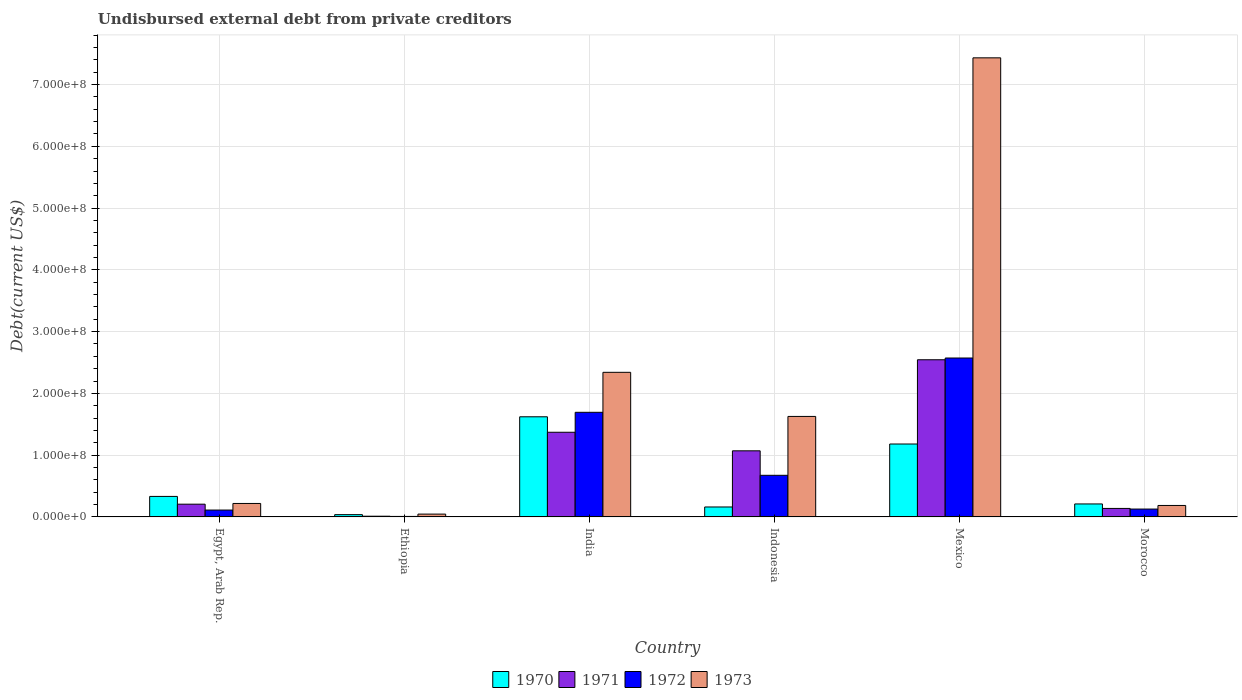How many different coloured bars are there?
Offer a terse response. 4. Are the number of bars on each tick of the X-axis equal?
Your answer should be very brief. Yes. How many bars are there on the 2nd tick from the left?
Your answer should be very brief. 4. What is the label of the 4th group of bars from the left?
Give a very brief answer. Indonesia. In how many cases, is the number of bars for a given country not equal to the number of legend labels?
Keep it short and to the point. 0. What is the total debt in 1971 in Indonesia?
Your answer should be very brief. 1.07e+08. Across all countries, what is the maximum total debt in 1970?
Your response must be concise. 1.62e+08. Across all countries, what is the minimum total debt in 1971?
Provide a succinct answer. 1.16e+06. In which country was the total debt in 1972 maximum?
Offer a very short reply. Mexico. In which country was the total debt in 1971 minimum?
Your answer should be compact. Ethiopia. What is the total total debt in 1971 in the graph?
Offer a very short reply. 5.34e+08. What is the difference between the total debt in 1973 in Egypt, Arab Rep. and that in India?
Your response must be concise. -2.12e+08. What is the difference between the total debt in 1972 in Mexico and the total debt in 1970 in India?
Your answer should be very brief. 9.51e+07. What is the average total debt in 1970 per country?
Ensure brevity in your answer.  5.90e+07. What is the difference between the total debt of/in 1973 and total debt of/in 1970 in Indonesia?
Make the answer very short. 1.47e+08. In how many countries, is the total debt in 1973 greater than 700000000 US$?
Provide a short and direct response. 1. What is the ratio of the total debt in 1973 in Ethiopia to that in India?
Make the answer very short. 0.02. Is the total debt in 1971 in Egypt, Arab Rep. less than that in Indonesia?
Your response must be concise. Yes. Is the difference between the total debt in 1973 in India and Indonesia greater than the difference between the total debt in 1970 in India and Indonesia?
Ensure brevity in your answer.  No. What is the difference between the highest and the second highest total debt in 1972?
Offer a terse response. 1.90e+08. What is the difference between the highest and the lowest total debt in 1970?
Make the answer very short. 1.58e+08. Is the sum of the total debt in 1973 in India and Indonesia greater than the maximum total debt in 1972 across all countries?
Keep it short and to the point. Yes. What does the 1st bar from the left in Mexico represents?
Offer a terse response. 1970. How many countries are there in the graph?
Give a very brief answer. 6. Does the graph contain grids?
Offer a terse response. Yes. How many legend labels are there?
Provide a short and direct response. 4. How are the legend labels stacked?
Give a very brief answer. Horizontal. What is the title of the graph?
Provide a short and direct response. Undisbursed external debt from private creditors. What is the label or title of the X-axis?
Make the answer very short. Country. What is the label or title of the Y-axis?
Keep it short and to the point. Debt(current US$). What is the Debt(current US$) in 1970 in Egypt, Arab Rep.?
Offer a very short reply. 3.32e+07. What is the Debt(current US$) of 1971 in Egypt, Arab Rep.?
Provide a succinct answer. 2.06e+07. What is the Debt(current US$) in 1972 in Egypt, Arab Rep.?
Offer a very short reply. 1.11e+07. What is the Debt(current US$) of 1973 in Egypt, Arab Rep.?
Ensure brevity in your answer.  2.18e+07. What is the Debt(current US$) in 1970 in Ethiopia?
Ensure brevity in your answer.  3.70e+06. What is the Debt(current US$) of 1971 in Ethiopia?
Offer a terse response. 1.16e+06. What is the Debt(current US$) of 1972 in Ethiopia?
Keep it short and to the point. 8.20e+05. What is the Debt(current US$) in 1973 in Ethiopia?
Provide a short and direct response. 4.57e+06. What is the Debt(current US$) in 1970 in India?
Your answer should be very brief. 1.62e+08. What is the Debt(current US$) of 1971 in India?
Give a very brief answer. 1.37e+08. What is the Debt(current US$) of 1972 in India?
Offer a very short reply. 1.69e+08. What is the Debt(current US$) in 1973 in India?
Offer a very short reply. 2.34e+08. What is the Debt(current US$) in 1970 in Indonesia?
Make the answer very short. 1.61e+07. What is the Debt(current US$) of 1971 in Indonesia?
Offer a very short reply. 1.07e+08. What is the Debt(current US$) in 1972 in Indonesia?
Offer a very short reply. 6.74e+07. What is the Debt(current US$) in 1973 in Indonesia?
Ensure brevity in your answer.  1.63e+08. What is the Debt(current US$) of 1970 in Mexico?
Give a very brief answer. 1.18e+08. What is the Debt(current US$) of 1971 in Mexico?
Ensure brevity in your answer.  2.54e+08. What is the Debt(current US$) in 1972 in Mexico?
Keep it short and to the point. 2.57e+08. What is the Debt(current US$) of 1973 in Mexico?
Ensure brevity in your answer.  7.43e+08. What is the Debt(current US$) of 1970 in Morocco?
Your response must be concise. 2.10e+07. What is the Debt(current US$) in 1971 in Morocco?
Ensure brevity in your answer.  1.37e+07. What is the Debt(current US$) of 1972 in Morocco?
Keep it short and to the point. 1.27e+07. What is the Debt(current US$) of 1973 in Morocco?
Offer a very short reply. 1.86e+07. Across all countries, what is the maximum Debt(current US$) of 1970?
Your answer should be very brief. 1.62e+08. Across all countries, what is the maximum Debt(current US$) of 1971?
Make the answer very short. 2.54e+08. Across all countries, what is the maximum Debt(current US$) of 1972?
Your response must be concise. 2.57e+08. Across all countries, what is the maximum Debt(current US$) in 1973?
Provide a succinct answer. 7.43e+08. Across all countries, what is the minimum Debt(current US$) in 1970?
Your response must be concise. 3.70e+06. Across all countries, what is the minimum Debt(current US$) in 1971?
Provide a short and direct response. 1.16e+06. Across all countries, what is the minimum Debt(current US$) in 1972?
Offer a terse response. 8.20e+05. Across all countries, what is the minimum Debt(current US$) in 1973?
Make the answer very short. 4.57e+06. What is the total Debt(current US$) of 1970 in the graph?
Make the answer very short. 3.54e+08. What is the total Debt(current US$) in 1971 in the graph?
Provide a succinct answer. 5.34e+08. What is the total Debt(current US$) of 1972 in the graph?
Provide a short and direct response. 5.19e+08. What is the total Debt(current US$) in 1973 in the graph?
Give a very brief answer. 1.18e+09. What is the difference between the Debt(current US$) of 1970 in Egypt, Arab Rep. and that in Ethiopia?
Offer a terse response. 2.95e+07. What is the difference between the Debt(current US$) in 1971 in Egypt, Arab Rep. and that in Ethiopia?
Provide a short and direct response. 1.95e+07. What is the difference between the Debt(current US$) of 1972 in Egypt, Arab Rep. and that in Ethiopia?
Keep it short and to the point. 1.03e+07. What is the difference between the Debt(current US$) of 1973 in Egypt, Arab Rep. and that in Ethiopia?
Offer a terse response. 1.72e+07. What is the difference between the Debt(current US$) in 1970 in Egypt, Arab Rep. and that in India?
Ensure brevity in your answer.  -1.29e+08. What is the difference between the Debt(current US$) in 1971 in Egypt, Arab Rep. and that in India?
Keep it short and to the point. -1.16e+08. What is the difference between the Debt(current US$) of 1972 in Egypt, Arab Rep. and that in India?
Give a very brief answer. -1.58e+08. What is the difference between the Debt(current US$) in 1973 in Egypt, Arab Rep. and that in India?
Provide a succinct answer. -2.12e+08. What is the difference between the Debt(current US$) in 1970 in Egypt, Arab Rep. and that in Indonesia?
Ensure brevity in your answer.  1.71e+07. What is the difference between the Debt(current US$) in 1971 in Egypt, Arab Rep. and that in Indonesia?
Your answer should be very brief. -8.64e+07. What is the difference between the Debt(current US$) of 1972 in Egypt, Arab Rep. and that in Indonesia?
Keep it short and to the point. -5.62e+07. What is the difference between the Debt(current US$) of 1973 in Egypt, Arab Rep. and that in Indonesia?
Ensure brevity in your answer.  -1.41e+08. What is the difference between the Debt(current US$) of 1970 in Egypt, Arab Rep. and that in Mexico?
Make the answer very short. -8.48e+07. What is the difference between the Debt(current US$) of 1971 in Egypt, Arab Rep. and that in Mexico?
Your answer should be very brief. -2.34e+08. What is the difference between the Debt(current US$) in 1972 in Egypt, Arab Rep. and that in Mexico?
Make the answer very short. -2.46e+08. What is the difference between the Debt(current US$) in 1973 in Egypt, Arab Rep. and that in Mexico?
Keep it short and to the point. -7.21e+08. What is the difference between the Debt(current US$) of 1970 in Egypt, Arab Rep. and that in Morocco?
Your response must be concise. 1.22e+07. What is the difference between the Debt(current US$) in 1971 in Egypt, Arab Rep. and that in Morocco?
Provide a short and direct response. 6.88e+06. What is the difference between the Debt(current US$) of 1972 in Egypt, Arab Rep. and that in Morocco?
Your answer should be compact. -1.61e+06. What is the difference between the Debt(current US$) in 1973 in Egypt, Arab Rep. and that in Morocco?
Your answer should be very brief. 3.24e+06. What is the difference between the Debt(current US$) in 1970 in Ethiopia and that in India?
Provide a short and direct response. -1.58e+08. What is the difference between the Debt(current US$) of 1971 in Ethiopia and that in India?
Offer a very short reply. -1.36e+08. What is the difference between the Debt(current US$) in 1972 in Ethiopia and that in India?
Your answer should be very brief. -1.69e+08. What is the difference between the Debt(current US$) of 1973 in Ethiopia and that in India?
Ensure brevity in your answer.  -2.30e+08. What is the difference between the Debt(current US$) of 1970 in Ethiopia and that in Indonesia?
Offer a very short reply. -1.24e+07. What is the difference between the Debt(current US$) in 1971 in Ethiopia and that in Indonesia?
Give a very brief answer. -1.06e+08. What is the difference between the Debt(current US$) of 1972 in Ethiopia and that in Indonesia?
Make the answer very short. -6.66e+07. What is the difference between the Debt(current US$) of 1973 in Ethiopia and that in Indonesia?
Your answer should be very brief. -1.58e+08. What is the difference between the Debt(current US$) in 1970 in Ethiopia and that in Mexico?
Give a very brief answer. -1.14e+08. What is the difference between the Debt(current US$) of 1971 in Ethiopia and that in Mexico?
Make the answer very short. -2.53e+08. What is the difference between the Debt(current US$) in 1972 in Ethiopia and that in Mexico?
Your answer should be compact. -2.56e+08. What is the difference between the Debt(current US$) of 1973 in Ethiopia and that in Mexico?
Offer a very short reply. -7.39e+08. What is the difference between the Debt(current US$) of 1970 in Ethiopia and that in Morocco?
Your answer should be very brief. -1.73e+07. What is the difference between the Debt(current US$) in 1971 in Ethiopia and that in Morocco?
Your answer should be compact. -1.26e+07. What is the difference between the Debt(current US$) in 1972 in Ethiopia and that in Morocco?
Keep it short and to the point. -1.19e+07. What is the difference between the Debt(current US$) in 1973 in Ethiopia and that in Morocco?
Give a very brief answer. -1.40e+07. What is the difference between the Debt(current US$) of 1970 in India and that in Indonesia?
Offer a very short reply. 1.46e+08. What is the difference between the Debt(current US$) in 1971 in India and that in Indonesia?
Keep it short and to the point. 3.00e+07. What is the difference between the Debt(current US$) of 1972 in India and that in Indonesia?
Offer a terse response. 1.02e+08. What is the difference between the Debt(current US$) in 1973 in India and that in Indonesia?
Make the answer very short. 7.14e+07. What is the difference between the Debt(current US$) in 1970 in India and that in Mexico?
Provide a succinct answer. 4.41e+07. What is the difference between the Debt(current US$) in 1971 in India and that in Mexico?
Offer a very short reply. -1.17e+08. What is the difference between the Debt(current US$) of 1972 in India and that in Mexico?
Your answer should be very brief. -8.79e+07. What is the difference between the Debt(current US$) in 1973 in India and that in Mexico?
Ensure brevity in your answer.  -5.09e+08. What is the difference between the Debt(current US$) of 1970 in India and that in Morocco?
Ensure brevity in your answer.  1.41e+08. What is the difference between the Debt(current US$) in 1971 in India and that in Morocco?
Make the answer very short. 1.23e+08. What is the difference between the Debt(current US$) of 1972 in India and that in Morocco?
Give a very brief answer. 1.57e+08. What is the difference between the Debt(current US$) of 1973 in India and that in Morocco?
Ensure brevity in your answer.  2.16e+08. What is the difference between the Debt(current US$) of 1970 in Indonesia and that in Mexico?
Ensure brevity in your answer.  -1.02e+08. What is the difference between the Debt(current US$) of 1971 in Indonesia and that in Mexico?
Offer a very short reply. -1.47e+08. What is the difference between the Debt(current US$) in 1972 in Indonesia and that in Mexico?
Your answer should be very brief. -1.90e+08. What is the difference between the Debt(current US$) of 1973 in Indonesia and that in Mexico?
Offer a very short reply. -5.81e+08. What is the difference between the Debt(current US$) in 1970 in Indonesia and that in Morocco?
Offer a very short reply. -4.89e+06. What is the difference between the Debt(current US$) in 1971 in Indonesia and that in Morocco?
Provide a succinct answer. 9.33e+07. What is the difference between the Debt(current US$) in 1972 in Indonesia and that in Morocco?
Give a very brief answer. 5.46e+07. What is the difference between the Debt(current US$) in 1973 in Indonesia and that in Morocco?
Offer a terse response. 1.44e+08. What is the difference between the Debt(current US$) in 1970 in Mexico and that in Morocco?
Keep it short and to the point. 9.70e+07. What is the difference between the Debt(current US$) in 1971 in Mexico and that in Morocco?
Your response must be concise. 2.41e+08. What is the difference between the Debt(current US$) in 1972 in Mexico and that in Morocco?
Your response must be concise. 2.45e+08. What is the difference between the Debt(current US$) in 1973 in Mexico and that in Morocco?
Keep it short and to the point. 7.25e+08. What is the difference between the Debt(current US$) in 1970 in Egypt, Arab Rep. and the Debt(current US$) in 1971 in Ethiopia?
Provide a succinct answer. 3.21e+07. What is the difference between the Debt(current US$) in 1970 in Egypt, Arab Rep. and the Debt(current US$) in 1972 in Ethiopia?
Ensure brevity in your answer.  3.24e+07. What is the difference between the Debt(current US$) of 1970 in Egypt, Arab Rep. and the Debt(current US$) of 1973 in Ethiopia?
Provide a succinct answer. 2.87e+07. What is the difference between the Debt(current US$) in 1971 in Egypt, Arab Rep. and the Debt(current US$) in 1972 in Ethiopia?
Your answer should be very brief. 1.98e+07. What is the difference between the Debt(current US$) of 1971 in Egypt, Arab Rep. and the Debt(current US$) of 1973 in Ethiopia?
Provide a succinct answer. 1.61e+07. What is the difference between the Debt(current US$) of 1972 in Egypt, Arab Rep. and the Debt(current US$) of 1973 in Ethiopia?
Give a very brief answer. 6.56e+06. What is the difference between the Debt(current US$) of 1970 in Egypt, Arab Rep. and the Debt(current US$) of 1971 in India?
Ensure brevity in your answer.  -1.04e+08. What is the difference between the Debt(current US$) of 1970 in Egypt, Arab Rep. and the Debt(current US$) of 1972 in India?
Provide a succinct answer. -1.36e+08. What is the difference between the Debt(current US$) of 1970 in Egypt, Arab Rep. and the Debt(current US$) of 1973 in India?
Provide a succinct answer. -2.01e+08. What is the difference between the Debt(current US$) of 1971 in Egypt, Arab Rep. and the Debt(current US$) of 1972 in India?
Your answer should be very brief. -1.49e+08. What is the difference between the Debt(current US$) of 1971 in Egypt, Arab Rep. and the Debt(current US$) of 1973 in India?
Your answer should be compact. -2.13e+08. What is the difference between the Debt(current US$) in 1972 in Egypt, Arab Rep. and the Debt(current US$) in 1973 in India?
Your response must be concise. -2.23e+08. What is the difference between the Debt(current US$) of 1970 in Egypt, Arab Rep. and the Debt(current US$) of 1971 in Indonesia?
Provide a succinct answer. -7.38e+07. What is the difference between the Debt(current US$) of 1970 in Egypt, Arab Rep. and the Debt(current US$) of 1972 in Indonesia?
Offer a terse response. -3.42e+07. What is the difference between the Debt(current US$) of 1970 in Egypt, Arab Rep. and the Debt(current US$) of 1973 in Indonesia?
Your response must be concise. -1.29e+08. What is the difference between the Debt(current US$) of 1971 in Egypt, Arab Rep. and the Debt(current US$) of 1972 in Indonesia?
Provide a short and direct response. -4.67e+07. What is the difference between the Debt(current US$) of 1971 in Egypt, Arab Rep. and the Debt(current US$) of 1973 in Indonesia?
Offer a terse response. -1.42e+08. What is the difference between the Debt(current US$) in 1972 in Egypt, Arab Rep. and the Debt(current US$) in 1973 in Indonesia?
Give a very brief answer. -1.52e+08. What is the difference between the Debt(current US$) of 1970 in Egypt, Arab Rep. and the Debt(current US$) of 1971 in Mexico?
Make the answer very short. -2.21e+08. What is the difference between the Debt(current US$) in 1970 in Egypt, Arab Rep. and the Debt(current US$) in 1972 in Mexico?
Offer a terse response. -2.24e+08. What is the difference between the Debt(current US$) in 1970 in Egypt, Arab Rep. and the Debt(current US$) in 1973 in Mexico?
Offer a terse response. -7.10e+08. What is the difference between the Debt(current US$) in 1971 in Egypt, Arab Rep. and the Debt(current US$) in 1972 in Mexico?
Provide a succinct answer. -2.37e+08. What is the difference between the Debt(current US$) of 1971 in Egypt, Arab Rep. and the Debt(current US$) of 1973 in Mexico?
Make the answer very short. -7.23e+08. What is the difference between the Debt(current US$) of 1972 in Egypt, Arab Rep. and the Debt(current US$) of 1973 in Mexico?
Offer a terse response. -7.32e+08. What is the difference between the Debt(current US$) of 1970 in Egypt, Arab Rep. and the Debt(current US$) of 1971 in Morocco?
Your response must be concise. 1.95e+07. What is the difference between the Debt(current US$) of 1970 in Egypt, Arab Rep. and the Debt(current US$) of 1972 in Morocco?
Provide a succinct answer. 2.05e+07. What is the difference between the Debt(current US$) of 1970 in Egypt, Arab Rep. and the Debt(current US$) of 1973 in Morocco?
Provide a succinct answer. 1.47e+07. What is the difference between the Debt(current US$) in 1971 in Egypt, Arab Rep. and the Debt(current US$) in 1972 in Morocco?
Your answer should be compact. 7.90e+06. What is the difference between the Debt(current US$) of 1971 in Egypt, Arab Rep. and the Debt(current US$) of 1973 in Morocco?
Offer a terse response. 2.07e+06. What is the difference between the Debt(current US$) of 1972 in Egypt, Arab Rep. and the Debt(current US$) of 1973 in Morocco?
Provide a succinct answer. -7.43e+06. What is the difference between the Debt(current US$) of 1970 in Ethiopia and the Debt(current US$) of 1971 in India?
Keep it short and to the point. -1.33e+08. What is the difference between the Debt(current US$) in 1970 in Ethiopia and the Debt(current US$) in 1972 in India?
Make the answer very short. -1.66e+08. What is the difference between the Debt(current US$) of 1970 in Ethiopia and the Debt(current US$) of 1973 in India?
Keep it short and to the point. -2.30e+08. What is the difference between the Debt(current US$) in 1971 in Ethiopia and the Debt(current US$) in 1972 in India?
Make the answer very short. -1.68e+08. What is the difference between the Debt(current US$) in 1971 in Ethiopia and the Debt(current US$) in 1973 in India?
Make the answer very short. -2.33e+08. What is the difference between the Debt(current US$) in 1972 in Ethiopia and the Debt(current US$) in 1973 in India?
Make the answer very short. -2.33e+08. What is the difference between the Debt(current US$) of 1970 in Ethiopia and the Debt(current US$) of 1971 in Indonesia?
Offer a very short reply. -1.03e+08. What is the difference between the Debt(current US$) of 1970 in Ethiopia and the Debt(current US$) of 1972 in Indonesia?
Ensure brevity in your answer.  -6.37e+07. What is the difference between the Debt(current US$) of 1970 in Ethiopia and the Debt(current US$) of 1973 in Indonesia?
Provide a short and direct response. -1.59e+08. What is the difference between the Debt(current US$) of 1971 in Ethiopia and the Debt(current US$) of 1972 in Indonesia?
Your response must be concise. -6.62e+07. What is the difference between the Debt(current US$) of 1971 in Ethiopia and the Debt(current US$) of 1973 in Indonesia?
Your answer should be very brief. -1.62e+08. What is the difference between the Debt(current US$) of 1972 in Ethiopia and the Debt(current US$) of 1973 in Indonesia?
Provide a succinct answer. -1.62e+08. What is the difference between the Debt(current US$) of 1970 in Ethiopia and the Debt(current US$) of 1971 in Mexico?
Provide a short and direct response. -2.51e+08. What is the difference between the Debt(current US$) in 1970 in Ethiopia and the Debt(current US$) in 1972 in Mexico?
Give a very brief answer. -2.54e+08. What is the difference between the Debt(current US$) of 1970 in Ethiopia and the Debt(current US$) of 1973 in Mexico?
Your response must be concise. -7.40e+08. What is the difference between the Debt(current US$) of 1971 in Ethiopia and the Debt(current US$) of 1972 in Mexico?
Your answer should be very brief. -2.56e+08. What is the difference between the Debt(current US$) of 1971 in Ethiopia and the Debt(current US$) of 1973 in Mexico?
Your response must be concise. -7.42e+08. What is the difference between the Debt(current US$) of 1972 in Ethiopia and the Debt(current US$) of 1973 in Mexico?
Provide a short and direct response. -7.42e+08. What is the difference between the Debt(current US$) in 1970 in Ethiopia and the Debt(current US$) in 1971 in Morocco?
Make the answer very short. -1.01e+07. What is the difference between the Debt(current US$) in 1970 in Ethiopia and the Debt(current US$) in 1972 in Morocco?
Your answer should be compact. -9.04e+06. What is the difference between the Debt(current US$) in 1970 in Ethiopia and the Debt(current US$) in 1973 in Morocco?
Your response must be concise. -1.49e+07. What is the difference between the Debt(current US$) of 1971 in Ethiopia and the Debt(current US$) of 1972 in Morocco?
Offer a very short reply. -1.16e+07. What is the difference between the Debt(current US$) in 1971 in Ethiopia and the Debt(current US$) in 1973 in Morocco?
Offer a very short reply. -1.74e+07. What is the difference between the Debt(current US$) of 1972 in Ethiopia and the Debt(current US$) of 1973 in Morocco?
Give a very brief answer. -1.77e+07. What is the difference between the Debt(current US$) of 1970 in India and the Debt(current US$) of 1971 in Indonesia?
Give a very brief answer. 5.51e+07. What is the difference between the Debt(current US$) of 1970 in India and the Debt(current US$) of 1972 in Indonesia?
Your answer should be compact. 9.47e+07. What is the difference between the Debt(current US$) of 1970 in India and the Debt(current US$) of 1973 in Indonesia?
Your response must be concise. -5.84e+05. What is the difference between the Debt(current US$) of 1971 in India and the Debt(current US$) of 1972 in Indonesia?
Make the answer very short. 6.97e+07. What is the difference between the Debt(current US$) of 1971 in India and the Debt(current US$) of 1973 in Indonesia?
Ensure brevity in your answer.  -2.56e+07. What is the difference between the Debt(current US$) of 1972 in India and the Debt(current US$) of 1973 in Indonesia?
Your answer should be very brief. 6.68e+06. What is the difference between the Debt(current US$) in 1970 in India and the Debt(current US$) in 1971 in Mexico?
Provide a short and direct response. -9.23e+07. What is the difference between the Debt(current US$) in 1970 in India and the Debt(current US$) in 1972 in Mexico?
Offer a very short reply. -9.51e+07. What is the difference between the Debt(current US$) in 1970 in India and the Debt(current US$) in 1973 in Mexico?
Your response must be concise. -5.81e+08. What is the difference between the Debt(current US$) in 1971 in India and the Debt(current US$) in 1972 in Mexico?
Offer a very short reply. -1.20e+08. What is the difference between the Debt(current US$) of 1971 in India and the Debt(current US$) of 1973 in Mexico?
Make the answer very short. -6.06e+08. What is the difference between the Debt(current US$) of 1972 in India and the Debt(current US$) of 1973 in Mexico?
Offer a very short reply. -5.74e+08. What is the difference between the Debt(current US$) in 1970 in India and the Debt(current US$) in 1971 in Morocco?
Keep it short and to the point. 1.48e+08. What is the difference between the Debt(current US$) in 1970 in India and the Debt(current US$) in 1972 in Morocco?
Offer a terse response. 1.49e+08. What is the difference between the Debt(current US$) of 1970 in India and the Debt(current US$) of 1973 in Morocco?
Your answer should be compact. 1.44e+08. What is the difference between the Debt(current US$) in 1971 in India and the Debt(current US$) in 1972 in Morocco?
Provide a succinct answer. 1.24e+08. What is the difference between the Debt(current US$) in 1971 in India and the Debt(current US$) in 1973 in Morocco?
Your response must be concise. 1.19e+08. What is the difference between the Debt(current US$) of 1972 in India and the Debt(current US$) of 1973 in Morocco?
Your answer should be compact. 1.51e+08. What is the difference between the Debt(current US$) in 1970 in Indonesia and the Debt(current US$) in 1971 in Mexico?
Keep it short and to the point. -2.38e+08. What is the difference between the Debt(current US$) in 1970 in Indonesia and the Debt(current US$) in 1972 in Mexico?
Your answer should be compact. -2.41e+08. What is the difference between the Debt(current US$) of 1970 in Indonesia and the Debt(current US$) of 1973 in Mexico?
Provide a short and direct response. -7.27e+08. What is the difference between the Debt(current US$) in 1971 in Indonesia and the Debt(current US$) in 1972 in Mexico?
Your answer should be very brief. -1.50e+08. What is the difference between the Debt(current US$) of 1971 in Indonesia and the Debt(current US$) of 1973 in Mexico?
Keep it short and to the point. -6.36e+08. What is the difference between the Debt(current US$) in 1972 in Indonesia and the Debt(current US$) in 1973 in Mexico?
Provide a short and direct response. -6.76e+08. What is the difference between the Debt(current US$) of 1970 in Indonesia and the Debt(current US$) of 1971 in Morocco?
Provide a short and direct response. 2.38e+06. What is the difference between the Debt(current US$) of 1970 in Indonesia and the Debt(current US$) of 1972 in Morocco?
Provide a succinct answer. 3.39e+06. What is the difference between the Debt(current US$) of 1970 in Indonesia and the Debt(current US$) of 1973 in Morocco?
Make the answer very short. -2.44e+06. What is the difference between the Debt(current US$) in 1971 in Indonesia and the Debt(current US$) in 1972 in Morocco?
Make the answer very short. 9.43e+07. What is the difference between the Debt(current US$) in 1971 in Indonesia and the Debt(current US$) in 1973 in Morocco?
Provide a short and direct response. 8.85e+07. What is the difference between the Debt(current US$) of 1972 in Indonesia and the Debt(current US$) of 1973 in Morocco?
Offer a terse response. 4.88e+07. What is the difference between the Debt(current US$) in 1970 in Mexico and the Debt(current US$) in 1971 in Morocco?
Offer a terse response. 1.04e+08. What is the difference between the Debt(current US$) in 1970 in Mexico and the Debt(current US$) in 1972 in Morocco?
Make the answer very short. 1.05e+08. What is the difference between the Debt(current US$) of 1970 in Mexico and the Debt(current US$) of 1973 in Morocco?
Make the answer very short. 9.95e+07. What is the difference between the Debt(current US$) of 1971 in Mexico and the Debt(current US$) of 1972 in Morocco?
Keep it short and to the point. 2.42e+08. What is the difference between the Debt(current US$) of 1971 in Mexico and the Debt(current US$) of 1973 in Morocco?
Your answer should be very brief. 2.36e+08. What is the difference between the Debt(current US$) of 1972 in Mexico and the Debt(current US$) of 1973 in Morocco?
Keep it short and to the point. 2.39e+08. What is the average Debt(current US$) in 1970 per country?
Offer a very short reply. 5.90e+07. What is the average Debt(current US$) of 1971 per country?
Your answer should be compact. 8.90e+07. What is the average Debt(current US$) of 1972 per country?
Give a very brief answer. 8.65e+07. What is the average Debt(current US$) of 1973 per country?
Give a very brief answer. 1.97e+08. What is the difference between the Debt(current US$) of 1970 and Debt(current US$) of 1971 in Egypt, Arab Rep.?
Provide a succinct answer. 1.26e+07. What is the difference between the Debt(current US$) in 1970 and Debt(current US$) in 1972 in Egypt, Arab Rep.?
Your response must be concise. 2.21e+07. What is the difference between the Debt(current US$) of 1970 and Debt(current US$) of 1973 in Egypt, Arab Rep.?
Keep it short and to the point. 1.14e+07. What is the difference between the Debt(current US$) in 1971 and Debt(current US$) in 1972 in Egypt, Arab Rep.?
Offer a terse response. 9.50e+06. What is the difference between the Debt(current US$) in 1971 and Debt(current US$) in 1973 in Egypt, Arab Rep.?
Make the answer very short. -1.17e+06. What is the difference between the Debt(current US$) of 1972 and Debt(current US$) of 1973 in Egypt, Arab Rep.?
Make the answer very short. -1.07e+07. What is the difference between the Debt(current US$) of 1970 and Debt(current US$) of 1971 in Ethiopia?
Make the answer very short. 2.53e+06. What is the difference between the Debt(current US$) of 1970 and Debt(current US$) of 1972 in Ethiopia?
Your answer should be very brief. 2.88e+06. What is the difference between the Debt(current US$) of 1970 and Debt(current US$) of 1973 in Ethiopia?
Your response must be concise. -8.70e+05. What is the difference between the Debt(current US$) of 1971 and Debt(current US$) of 1972 in Ethiopia?
Your answer should be very brief. 3.45e+05. What is the difference between the Debt(current US$) in 1971 and Debt(current US$) in 1973 in Ethiopia?
Keep it short and to the point. -3.40e+06. What is the difference between the Debt(current US$) of 1972 and Debt(current US$) of 1973 in Ethiopia?
Provide a short and direct response. -3.75e+06. What is the difference between the Debt(current US$) in 1970 and Debt(current US$) in 1971 in India?
Your answer should be compact. 2.51e+07. What is the difference between the Debt(current US$) in 1970 and Debt(current US$) in 1972 in India?
Offer a very short reply. -7.26e+06. What is the difference between the Debt(current US$) of 1970 and Debt(current US$) of 1973 in India?
Keep it short and to the point. -7.20e+07. What is the difference between the Debt(current US$) in 1971 and Debt(current US$) in 1972 in India?
Provide a succinct answer. -3.23e+07. What is the difference between the Debt(current US$) in 1971 and Debt(current US$) in 1973 in India?
Your answer should be very brief. -9.70e+07. What is the difference between the Debt(current US$) in 1972 and Debt(current US$) in 1973 in India?
Offer a terse response. -6.47e+07. What is the difference between the Debt(current US$) of 1970 and Debt(current US$) of 1971 in Indonesia?
Provide a succinct answer. -9.09e+07. What is the difference between the Debt(current US$) in 1970 and Debt(current US$) in 1972 in Indonesia?
Your response must be concise. -5.12e+07. What is the difference between the Debt(current US$) of 1970 and Debt(current US$) of 1973 in Indonesia?
Provide a short and direct response. -1.47e+08. What is the difference between the Debt(current US$) in 1971 and Debt(current US$) in 1972 in Indonesia?
Provide a succinct answer. 3.96e+07. What is the difference between the Debt(current US$) of 1971 and Debt(current US$) of 1973 in Indonesia?
Your response must be concise. -5.57e+07. What is the difference between the Debt(current US$) of 1972 and Debt(current US$) of 1973 in Indonesia?
Give a very brief answer. -9.53e+07. What is the difference between the Debt(current US$) in 1970 and Debt(current US$) in 1971 in Mexico?
Provide a short and direct response. -1.36e+08. What is the difference between the Debt(current US$) in 1970 and Debt(current US$) in 1972 in Mexico?
Provide a short and direct response. -1.39e+08. What is the difference between the Debt(current US$) in 1970 and Debt(current US$) in 1973 in Mexico?
Ensure brevity in your answer.  -6.25e+08. What is the difference between the Debt(current US$) in 1971 and Debt(current US$) in 1972 in Mexico?
Offer a terse response. -2.84e+06. What is the difference between the Debt(current US$) of 1971 and Debt(current US$) of 1973 in Mexico?
Provide a short and direct response. -4.89e+08. What is the difference between the Debt(current US$) of 1972 and Debt(current US$) of 1973 in Mexico?
Your answer should be very brief. -4.86e+08. What is the difference between the Debt(current US$) in 1970 and Debt(current US$) in 1971 in Morocco?
Give a very brief answer. 7.27e+06. What is the difference between the Debt(current US$) in 1970 and Debt(current US$) in 1972 in Morocco?
Provide a short and direct response. 8.28e+06. What is the difference between the Debt(current US$) of 1970 and Debt(current US$) of 1973 in Morocco?
Offer a terse response. 2.45e+06. What is the difference between the Debt(current US$) of 1971 and Debt(current US$) of 1972 in Morocco?
Offer a very short reply. 1.01e+06. What is the difference between the Debt(current US$) of 1971 and Debt(current US$) of 1973 in Morocco?
Your answer should be very brief. -4.81e+06. What is the difference between the Debt(current US$) in 1972 and Debt(current US$) in 1973 in Morocco?
Your answer should be compact. -5.82e+06. What is the ratio of the Debt(current US$) in 1970 in Egypt, Arab Rep. to that in Ethiopia?
Offer a terse response. 8.99. What is the ratio of the Debt(current US$) of 1971 in Egypt, Arab Rep. to that in Ethiopia?
Give a very brief answer. 17.71. What is the ratio of the Debt(current US$) of 1972 in Egypt, Arab Rep. to that in Ethiopia?
Ensure brevity in your answer.  13.57. What is the ratio of the Debt(current US$) in 1973 in Egypt, Arab Rep. to that in Ethiopia?
Provide a succinct answer. 4.77. What is the ratio of the Debt(current US$) of 1970 in Egypt, Arab Rep. to that in India?
Provide a short and direct response. 0.2. What is the ratio of the Debt(current US$) of 1971 in Egypt, Arab Rep. to that in India?
Keep it short and to the point. 0.15. What is the ratio of the Debt(current US$) of 1972 in Egypt, Arab Rep. to that in India?
Ensure brevity in your answer.  0.07. What is the ratio of the Debt(current US$) of 1973 in Egypt, Arab Rep. to that in India?
Your answer should be very brief. 0.09. What is the ratio of the Debt(current US$) of 1970 in Egypt, Arab Rep. to that in Indonesia?
Keep it short and to the point. 2.06. What is the ratio of the Debt(current US$) of 1971 in Egypt, Arab Rep. to that in Indonesia?
Your answer should be very brief. 0.19. What is the ratio of the Debt(current US$) in 1972 in Egypt, Arab Rep. to that in Indonesia?
Offer a very short reply. 0.17. What is the ratio of the Debt(current US$) of 1973 in Egypt, Arab Rep. to that in Indonesia?
Provide a short and direct response. 0.13. What is the ratio of the Debt(current US$) in 1970 in Egypt, Arab Rep. to that in Mexico?
Keep it short and to the point. 0.28. What is the ratio of the Debt(current US$) in 1971 in Egypt, Arab Rep. to that in Mexico?
Give a very brief answer. 0.08. What is the ratio of the Debt(current US$) in 1972 in Egypt, Arab Rep. to that in Mexico?
Offer a very short reply. 0.04. What is the ratio of the Debt(current US$) in 1973 in Egypt, Arab Rep. to that in Mexico?
Your answer should be compact. 0.03. What is the ratio of the Debt(current US$) in 1970 in Egypt, Arab Rep. to that in Morocco?
Ensure brevity in your answer.  1.58. What is the ratio of the Debt(current US$) in 1971 in Egypt, Arab Rep. to that in Morocco?
Make the answer very short. 1.5. What is the ratio of the Debt(current US$) of 1972 in Egypt, Arab Rep. to that in Morocco?
Your answer should be very brief. 0.87. What is the ratio of the Debt(current US$) of 1973 in Egypt, Arab Rep. to that in Morocco?
Ensure brevity in your answer.  1.17. What is the ratio of the Debt(current US$) of 1970 in Ethiopia to that in India?
Provide a succinct answer. 0.02. What is the ratio of the Debt(current US$) in 1971 in Ethiopia to that in India?
Offer a very short reply. 0.01. What is the ratio of the Debt(current US$) of 1972 in Ethiopia to that in India?
Ensure brevity in your answer.  0. What is the ratio of the Debt(current US$) of 1973 in Ethiopia to that in India?
Offer a terse response. 0.02. What is the ratio of the Debt(current US$) of 1970 in Ethiopia to that in Indonesia?
Your answer should be compact. 0.23. What is the ratio of the Debt(current US$) of 1971 in Ethiopia to that in Indonesia?
Your answer should be very brief. 0.01. What is the ratio of the Debt(current US$) in 1972 in Ethiopia to that in Indonesia?
Your response must be concise. 0.01. What is the ratio of the Debt(current US$) of 1973 in Ethiopia to that in Indonesia?
Make the answer very short. 0.03. What is the ratio of the Debt(current US$) of 1970 in Ethiopia to that in Mexico?
Your answer should be very brief. 0.03. What is the ratio of the Debt(current US$) of 1971 in Ethiopia to that in Mexico?
Provide a succinct answer. 0. What is the ratio of the Debt(current US$) of 1972 in Ethiopia to that in Mexico?
Offer a terse response. 0. What is the ratio of the Debt(current US$) of 1973 in Ethiopia to that in Mexico?
Offer a very short reply. 0.01. What is the ratio of the Debt(current US$) of 1970 in Ethiopia to that in Morocco?
Offer a very short reply. 0.18. What is the ratio of the Debt(current US$) of 1971 in Ethiopia to that in Morocco?
Your response must be concise. 0.08. What is the ratio of the Debt(current US$) in 1972 in Ethiopia to that in Morocco?
Give a very brief answer. 0.06. What is the ratio of the Debt(current US$) of 1973 in Ethiopia to that in Morocco?
Make the answer very short. 0.25. What is the ratio of the Debt(current US$) in 1970 in India to that in Indonesia?
Your answer should be very brief. 10.05. What is the ratio of the Debt(current US$) of 1971 in India to that in Indonesia?
Provide a short and direct response. 1.28. What is the ratio of the Debt(current US$) in 1972 in India to that in Indonesia?
Offer a terse response. 2.51. What is the ratio of the Debt(current US$) of 1973 in India to that in Indonesia?
Your answer should be very brief. 1.44. What is the ratio of the Debt(current US$) of 1970 in India to that in Mexico?
Provide a short and direct response. 1.37. What is the ratio of the Debt(current US$) in 1971 in India to that in Mexico?
Your response must be concise. 0.54. What is the ratio of the Debt(current US$) of 1972 in India to that in Mexico?
Your response must be concise. 0.66. What is the ratio of the Debt(current US$) of 1973 in India to that in Mexico?
Your answer should be compact. 0.32. What is the ratio of the Debt(current US$) in 1970 in India to that in Morocco?
Keep it short and to the point. 7.71. What is the ratio of the Debt(current US$) of 1971 in India to that in Morocco?
Provide a short and direct response. 9.97. What is the ratio of the Debt(current US$) in 1972 in India to that in Morocco?
Your answer should be very brief. 13.3. What is the ratio of the Debt(current US$) of 1973 in India to that in Morocco?
Offer a terse response. 12.61. What is the ratio of the Debt(current US$) of 1970 in Indonesia to that in Mexico?
Offer a terse response. 0.14. What is the ratio of the Debt(current US$) in 1971 in Indonesia to that in Mexico?
Make the answer very short. 0.42. What is the ratio of the Debt(current US$) in 1972 in Indonesia to that in Mexico?
Provide a succinct answer. 0.26. What is the ratio of the Debt(current US$) of 1973 in Indonesia to that in Mexico?
Ensure brevity in your answer.  0.22. What is the ratio of the Debt(current US$) in 1970 in Indonesia to that in Morocco?
Provide a short and direct response. 0.77. What is the ratio of the Debt(current US$) in 1971 in Indonesia to that in Morocco?
Your answer should be very brief. 7.78. What is the ratio of the Debt(current US$) in 1972 in Indonesia to that in Morocco?
Provide a succinct answer. 5.29. What is the ratio of the Debt(current US$) in 1973 in Indonesia to that in Morocco?
Ensure brevity in your answer.  8.77. What is the ratio of the Debt(current US$) of 1970 in Mexico to that in Morocco?
Provide a succinct answer. 5.62. What is the ratio of the Debt(current US$) in 1971 in Mexico to that in Morocco?
Your answer should be compact. 18.51. What is the ratio of the Debt(current US$) of 1972 in Mexico to that in Morocco?
Ensure brevity in your answer.  20.2. What is the ratio of the Debt(current US$) of 1973 in Mexico to that in Morocco?
Ensure brevity in your answer.  40.04. What is the difference between the highest and the second highest Debt(current US$) of 1970?
Provide a short and direct response. 4.41e+07. What is the difference between the highest and the second highest Debt(current US$) of 1971?
Keep it short and to the point. 1.17e+08. What is the difference between the highest and the second highest Debt(current US$) in 1972?
Ensure brevity in your answer.  8.79e+07. What is the difference between the highest and the second highest Debt(current US$) in 1973?
Keep it short and to the point. 5.09e+08. What is the difference between the highest and the lowest Debt(current US$) in 1970?
Your answer should be very brief. 1.58e+08. What is the difference between the highest and the lowest Debt(current US$) of 1971?
Offer a very short reply. 2.53e+08. What is the difference between the highest and the lowest Debt(current US$) of 1972?
Provide a succinct answer. 2.56e+08. What is the difference between the highest and the lowest Debt(current US$) in 1973?
Your answer should be very brief. 7.39e+08. 